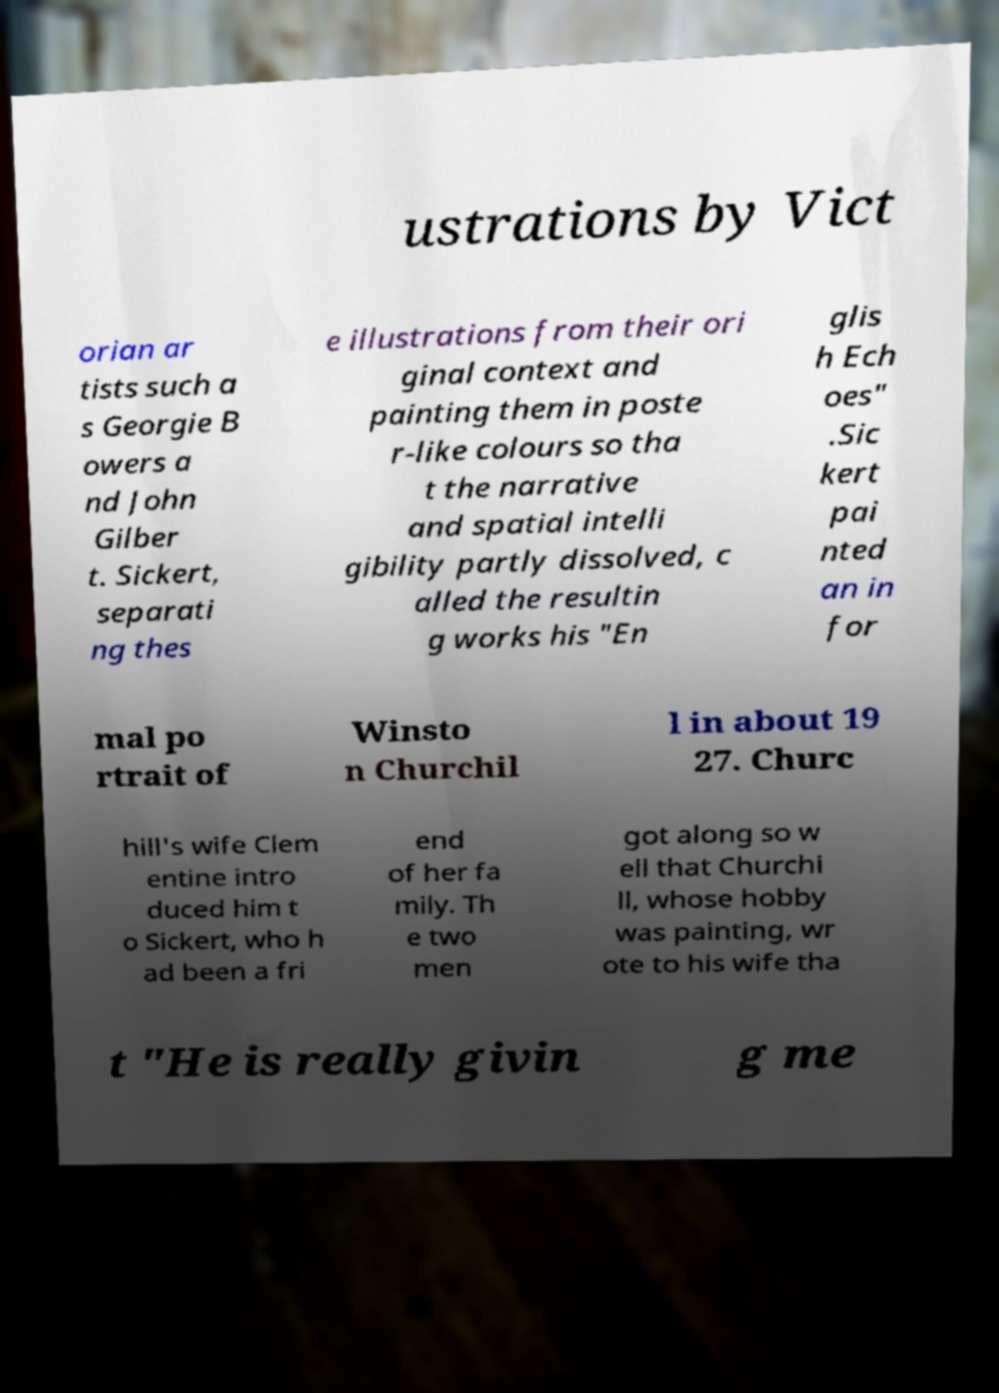Please identify and transcribe the text found in this image. ustrations by Vict orian ar tists such a s Georgie B owers a nd John Gilber t. Sickert, separati ng thes e illustrations from their ori ginal context and painting them in poste r-like colours so tha t the narrative and spatial intelli gibility partly dissolved, c alled the resultin g works his "En glis h Ech oes" .Sic kert pai nted an in for mal po rtrait of Winsto n Churchil l in about 19 27. Churc hill's wife Clem entine intro duced him t o Sickert, who h ad been a fri end of her fa mily. Th e two men got along so w ell that Churchi ll, whose hobby was painting, wr ote to his wife tha t "He is really givin g me 